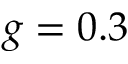<formula> <loc_0><loc_0><loc_500><loc_500>g = 0 . 3</formula> 